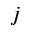Convert formula to latex. <formula><loc_0><loc_0><loc_500><loc_500>j</formula> 